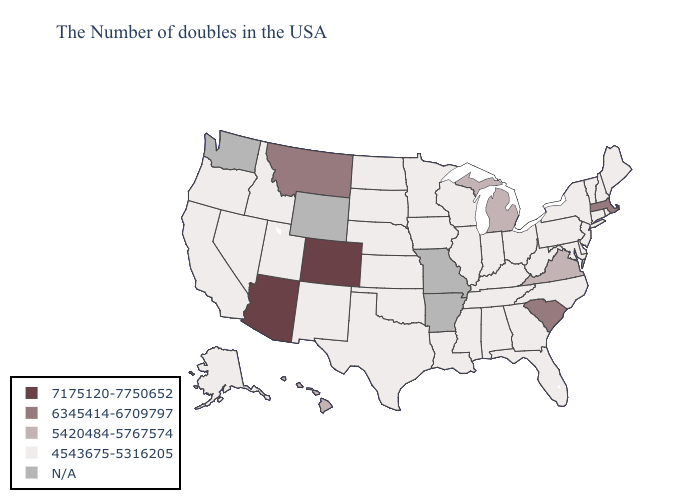Which states have the lowest value in the MidWest?
Answer briefly. Ohio, Indiana, Wisconsin, Illinois, Minnesota, Iowa, Kansas, Nebraska, South Dakota, North Dakota. What is the value of Nevada?
Short answer required. 4543675-5316205. Does Colorado have the lowest value in the West?
Be succinct. No. Does Michigan have the lowest value in the MidWest?
Answer briefly. No. What is the highest value in the USA?
Quick response, please. 7175120-7750652. Does Montana have the lowest value in the West?
Write a very short answer. No. Among the states that border New Hampshire , does Maine have the highest value?
Write a very short answer. No. What is the value of West Virginia?
Write a very short answer. 4543675-5316205. What is the value of Mississippi?
Answer briefly. 4543675-5316205. What is the value of Wyoming?
Be succinct. N/A. What is the highest value in the USA?
Quick response, please. 7175120-7750652. Name the states that have a value in the range 7175120-7750652?
Quick response, please. Colorado, Arizona. 